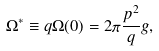Convert formula to latex. <formula><loc_0><loc_0><loc_500><loc_500>\Omega ^ { * } \equiv q \Omega ( 0 ) = 2 \pi \frac { p ^ { 2 } } q g ,</formula> 